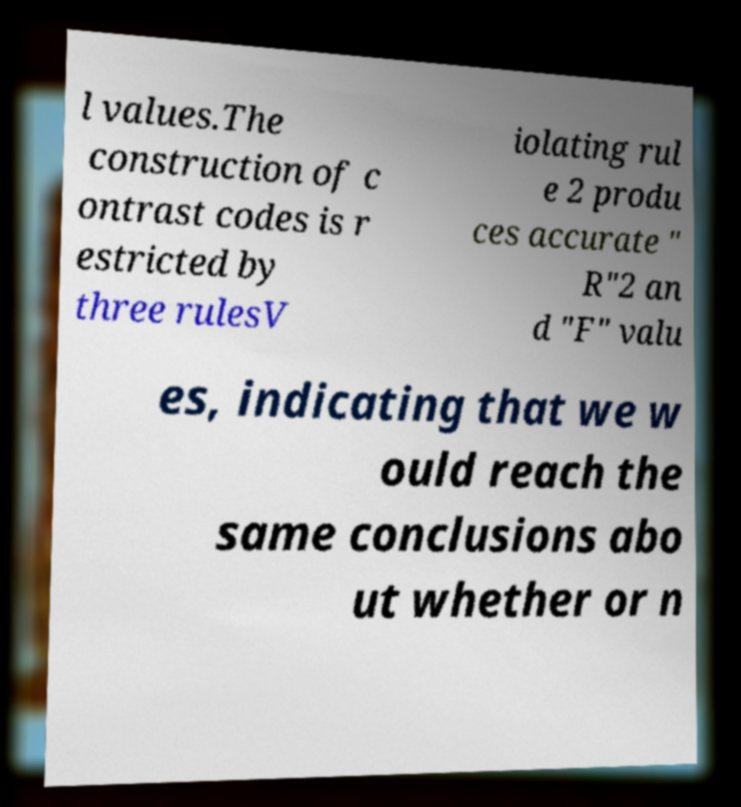Could you assist in decoding the text presented in this image and type it out clearly? l values.The construction of c ontrast codes is r estricted by three rulesV iolating rul e 2 produ ces accurate " R"2 an d "F" valu es, indicating that we w ould reach the same conclusions abo ut whether or n 